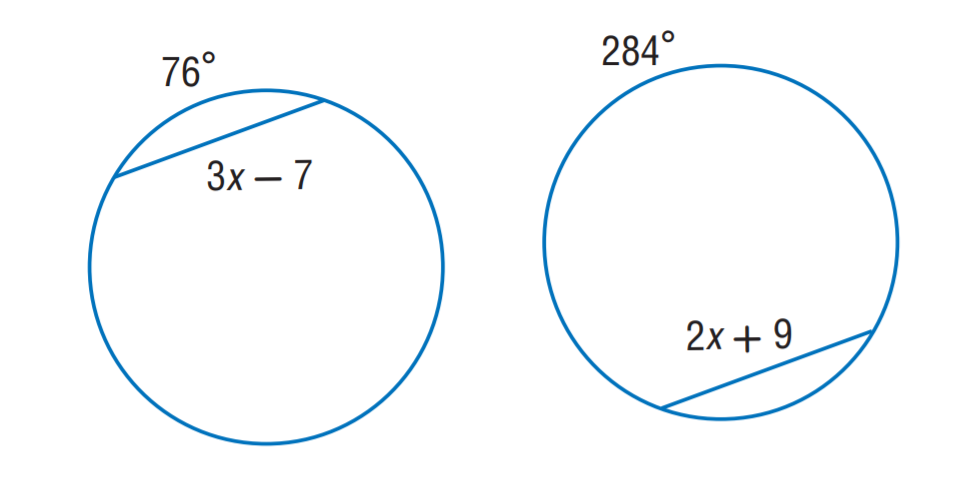Answer the mathemtical geometry problem and directly provide the correct option letter.
Question: The two circles are congruent. Find x.
Choices: A: 9 B: 16 C: 31 D: 41 B 